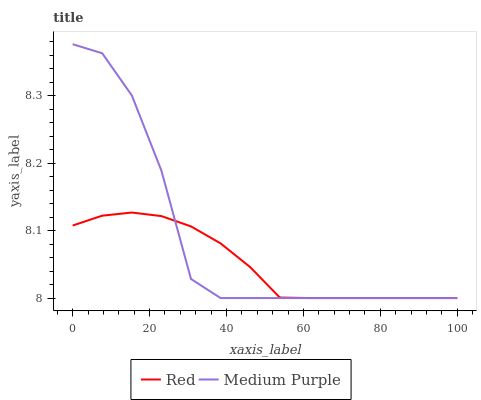Does Red have the minimum area under the curve?
Answer yes or no. Yes. Does Medium Purple have the maximum area under the curve?
Answer yes or no. Yes. Does Red have the maximum area under the curve?
Answer yes or no. No. Is Red the smoothest?
Answer yes or no. Yes. Is Medium Purple the roughest?
Answer yes or no. Yes. Is Red the roughest?
Answer yes or no. No. Does Medium Purple have the highest value?
Answer yes or no. Yes. Does Red have the highest value?
Answer yes or no. No. Does Medium Purple intersect Red?
Answer yes or no. Yes. Is Medium Purple less than Red?
Answer yes or no. No. Is Medium Purple greater than Red?
Answer yes or no. No. 